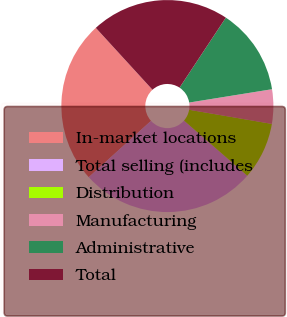Convert chart to OTSL. <chart><loc_0><loc_0><loc_500><loc_500><pie_chart><fcel>In-market locations<fcel>Total selling (includes<fcel>Distribution<fcel>Manufacturing<fcel>Administrative<fcel>Total<nl><fcel>24.9%<fcel>26.88%<fcel>8.72%<fcel>5.23%<fcel>13.16%<fcel>21.09%<nl></chart> 